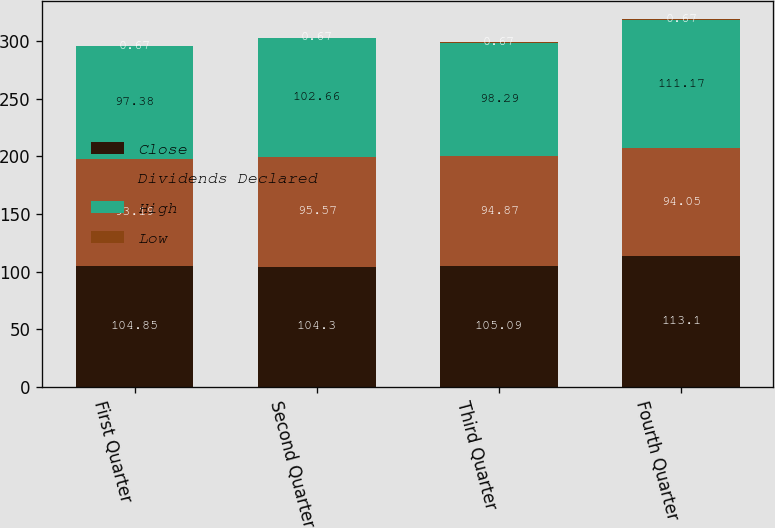<chart> <loc_0><loc_0><loc_500><loc_500><stacked_bar_chart><ecel><fcel>First Quarter<fcel>Second Quarter<fcel>Third Quarter<fcel>Fourth Quarter<nl><fcel>Close<fcel>104.85<fcel>104.3<fcel>105.09<fcel>113.1<nl><fcel>Dividends Declared<fcel>93.19<fcel>95.57<fcel>94.87<fcel>94.05<nl><fcel>High<fcel>97.38<fcel>102.66<fcel>98.29<fcel>111.17<nl><fcel>Low<fcel>0.67<fcel>0.67<fcel>0.67<fcel>0.67<nl></chart> 